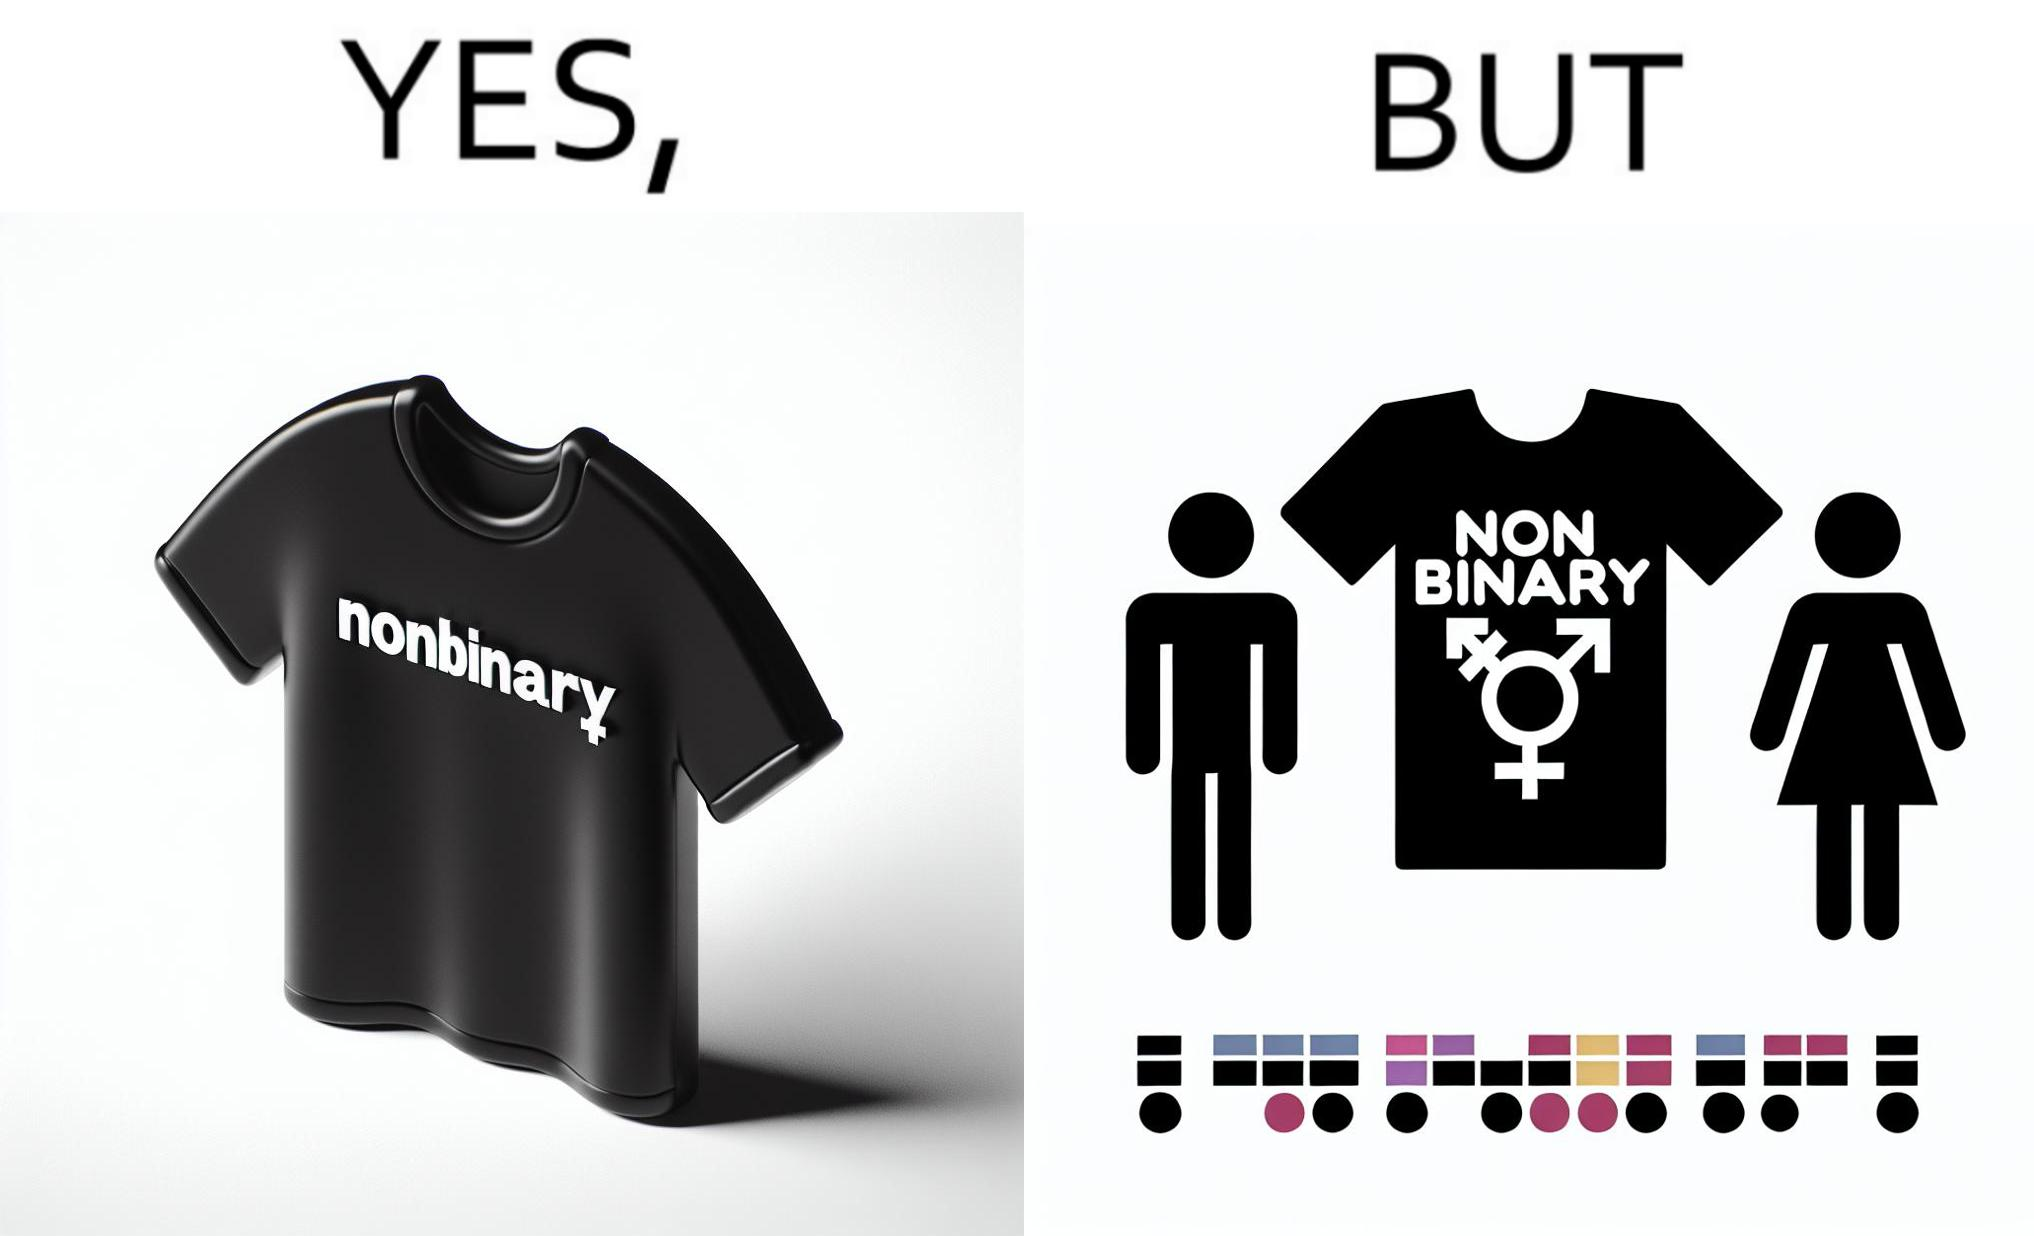Is this image satirical or non-satirical? Yes, this image is satirical. 